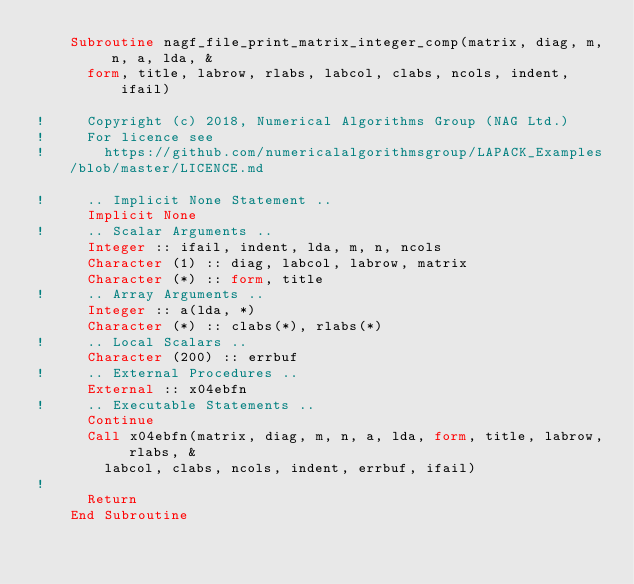Convert code to text. <code><loc_0><loc_0><loc_500><loc_500><_FORTRAN_>    Subroutine nagf_file_print_matrix_integer_comp(matrix, diag, m, n, a, lda, &
      form, title, labrow, rlabs, labcol, clabs, ncols, indent, ifail)

!     Copyright (c) 2018, Numerical Algorithms Group (NAG Ltd.)
!     For licence see
!       https://github.com/numericalalgorithmsgroup/LAPACK_Examples/blob/master/LICENCE.md

!     .. Implicit None Statement ..
      Implicit None
!     .. Scalar Arguments ..
      Integer :: ifail, indent, lda, m, n, ncols
      Character (1) :: diag, labcol, labrow, matrix
      Character (*) :: form, title
!     .. Array Arguments ..
      Integer :: a(lda, *)
      Character (*) :: clabs(*), rlabs(*)
!     .. Local Scalars ..
      Character (200) :: errbuf
!     .. External Procedures ..
      External :: x04ebfn
!     .. Executable Statements ..
      Continue
      Call x04ebfn(matrix, diag, m, n, a, lda, form, title, labrow, rlabs, &
        labcol, clabs, ncols, indent, errbuf, ifail)
!
      Return
    End Subroutine
</code> 